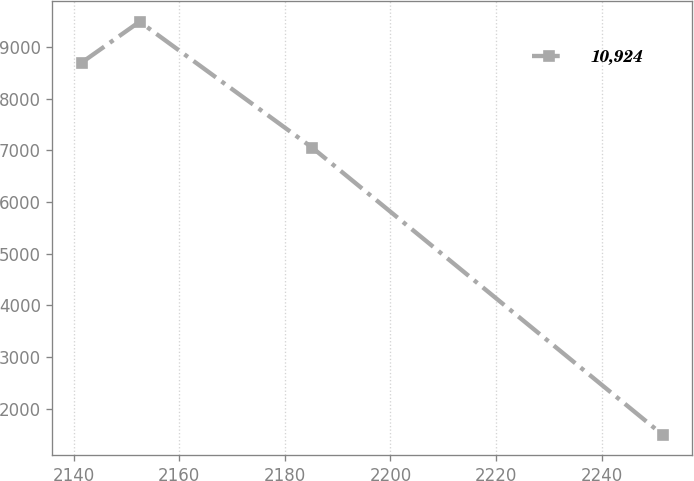Convert chart. <chart><loc_0><loc_0><loc_500><loc_500><line_chart><ecel><fcel>10,924<nl><fcel>2141.47<fcel>8693.43<nl><fcel>2152.48<fcel>9487.08<nl><fcel>2185.16<fcel>7050.93<nl><fcel>2251.58<fcel>1492.67<nl></chart> 